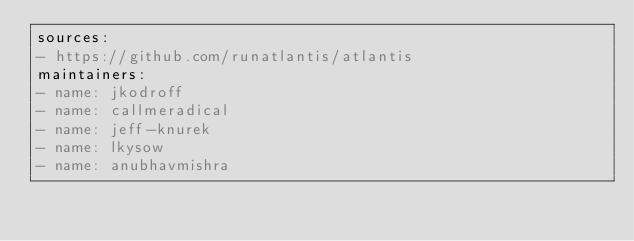<code> <loc_0><loc_0><loc_500><loc_500><_YAML_>sources:
- https://github.com/runatlantis/atlantis
maintainers:
- name: jkodroff
- name: callmeradical
- name: jeff-knurek
- name: lkysow
- name: anubhavmishra
</code> 